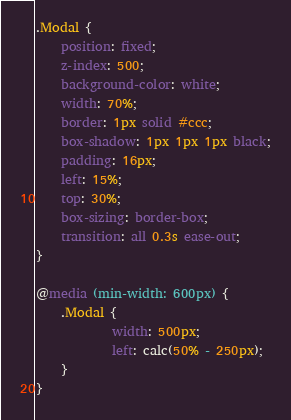Convert code to text. <code><loc_0><loc_0><loc_500><loc_500><_CSS_>.Modal {
	position: fixed;
	z-index: 500;
	background-color: white;
	width: 70%;
	border: 1px solid #ccc;
	box-shadow: 1px 1px 1px black;
	padding: 16px;
	left: 15%;
	top: 30%;
	box-sizing: border-box;
	transition: all 0.3s ease-out;
}

@media (min-width: 600px) {
	.Modal {
			width: 500px;
			left: calc(50% - 250px);
	}
}
</code> 